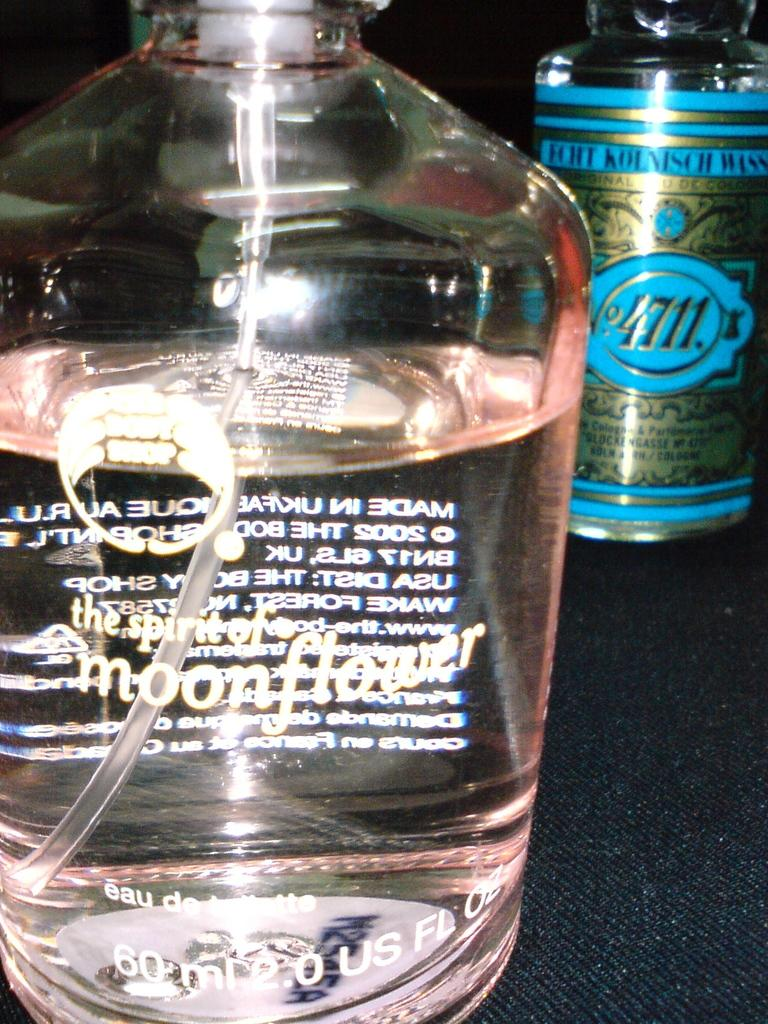What type of container is visible in the image? There is a transparent glass bottle in the image. What is inside the glass bottle? The bottle contains a liquid. What is written on the glass bottle? The word "moonflower" is written on the bottle. Are there any other bottles in the image? Yes, there is another bottle in the image. What is written on the second bottle? The number "4711" is written on the second bottle. Can you see any signs of trouble or prison in the image? There is no indication of trouble or prison in the image; it only features two bottles with labels. 